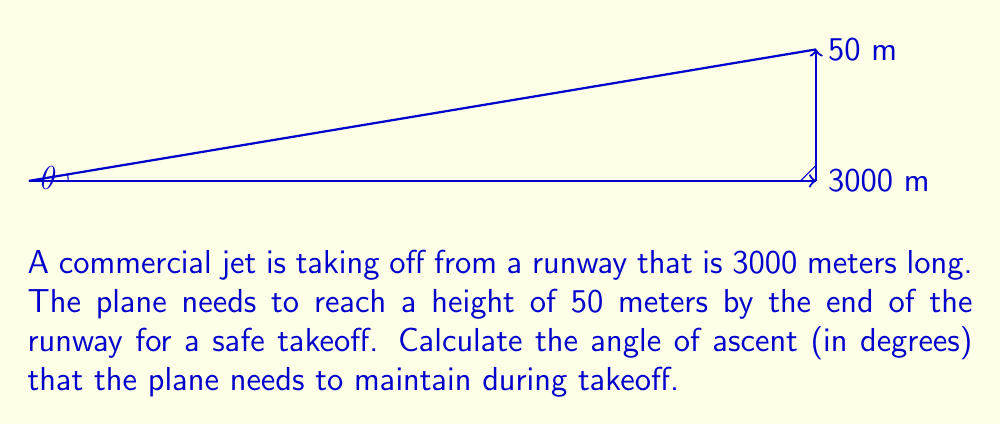Could you help me with this problem? Let's approach this step-by-step:

1) We can view this as a right-angled triangle, where:
   - The base of the triangle is the length of the runway (3000 m)
   - The height of the triangle is the required altitude (50 m)
   - The angle we're looking for is the angle of ascent

2) To find the angle, we can use the tangent function:

   $$ \tan(\theta) = \frac{\text{opposite}}{\text{adjacent}} = \frac{\text{height}}{\text{runway length}} $$

3) Plugging in our values:

   $$ \tan(\theta) = \frac{50}{3000} = \frac{1}{60} \approx 0.0167 $$

4) To get the angle, we need to use the inverse tangent (arctan) function:

   $$ \theta = \arctan(0.0167) $$

5) Using a calculator or computer:

   $$ \theta \approx 0.955° $$

6) Rounding to two decimal places:

   $$ \theta \approx 0.96° $$

This angle might seem small, but it's typical for commercial aircraft takeoffs, which usually occur at angles between 5° and 15°. The low angle in this problem ensures a gradual and safe ascent.
Answer: $0.96°$ 